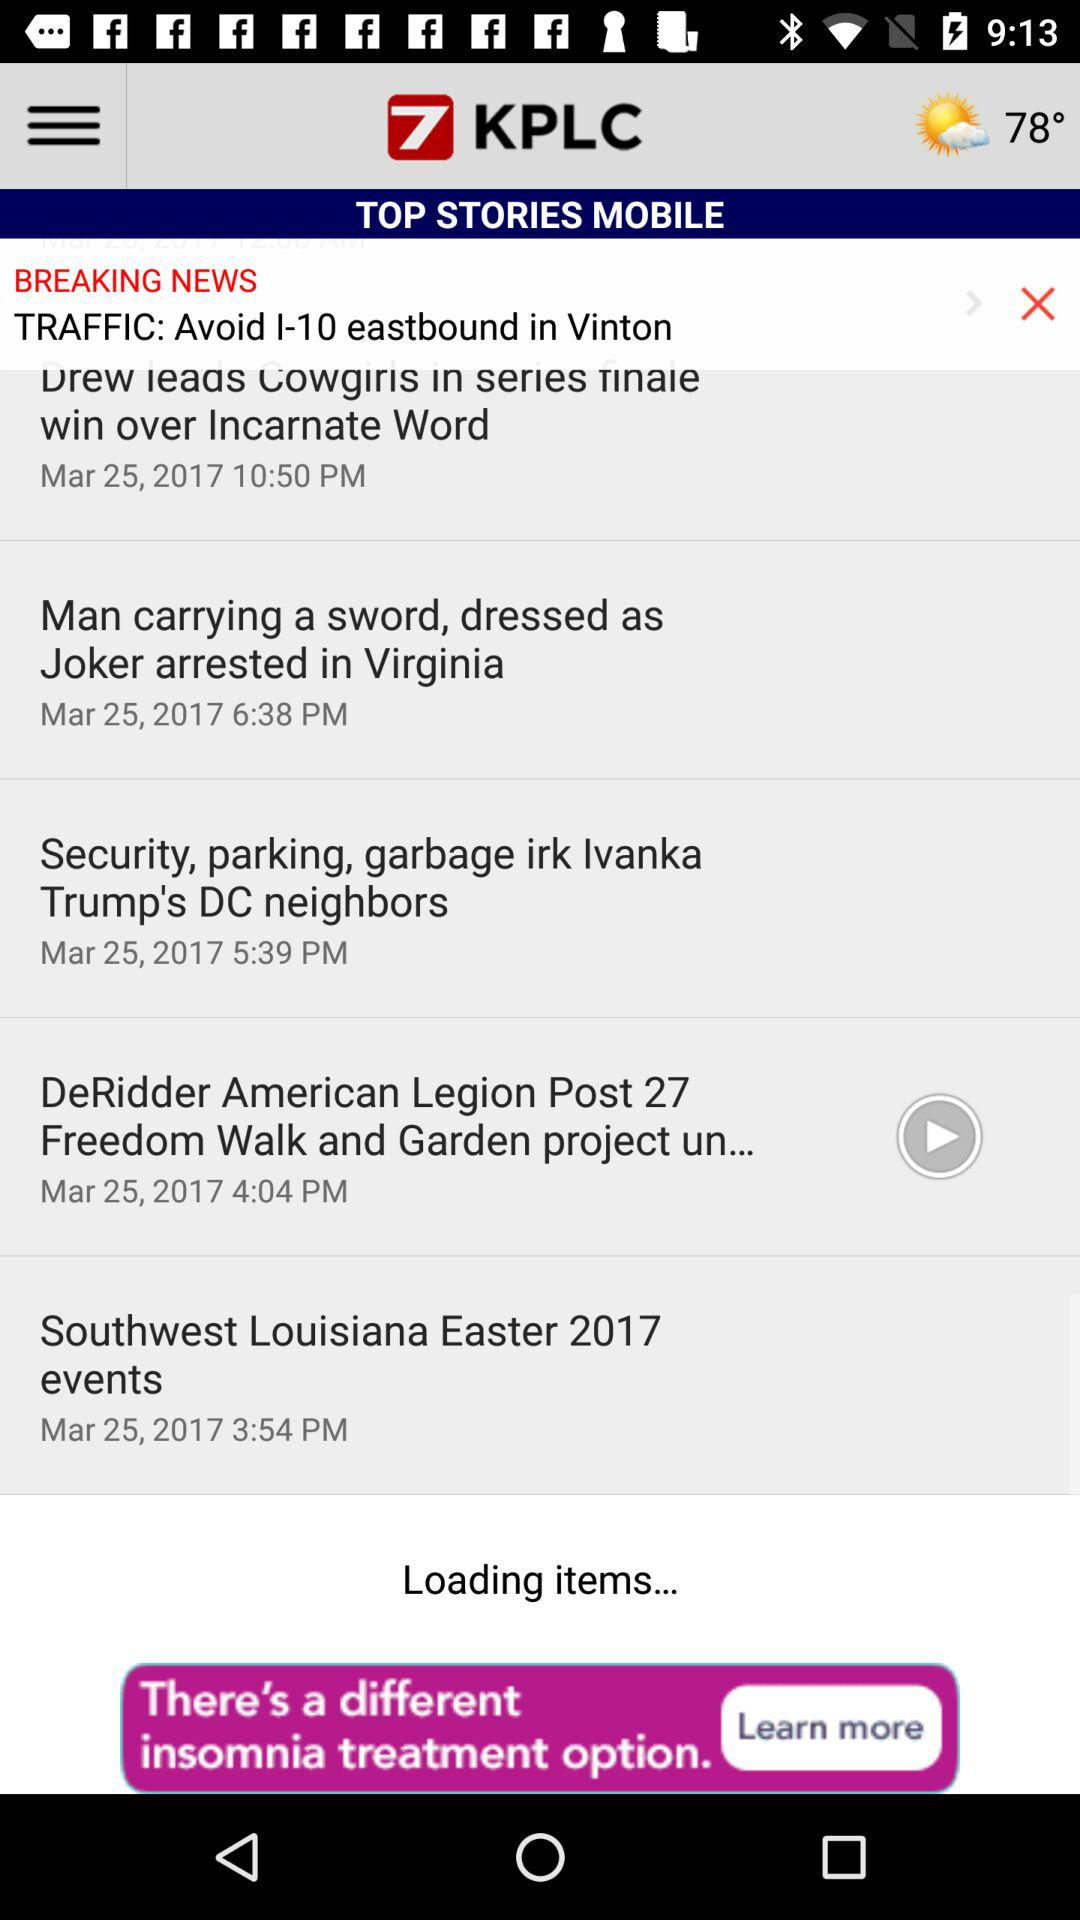What's the posted date of the "Southwest Louisiana Easter 2017 events"? The posted date is March 25, 2017. 